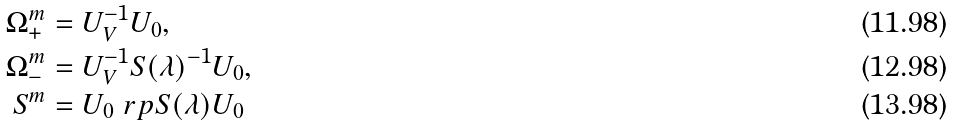<formula> <loc_0><loc_0><loc_500><loc_500>\Omega ^ { m } _ { + } & = U _ { V } ^ { - 1 } U _ { 0 } , \\ \Omega ^ { m } _ { - } & = U _ { V } ^ { - 1 } S ( \lambda ) ^ { - 1 } U _ { 0 } , \\ S ^ { m } & = U _ { 0 } \ r p S ( \lambda ) U _ { 0 }</formula> 